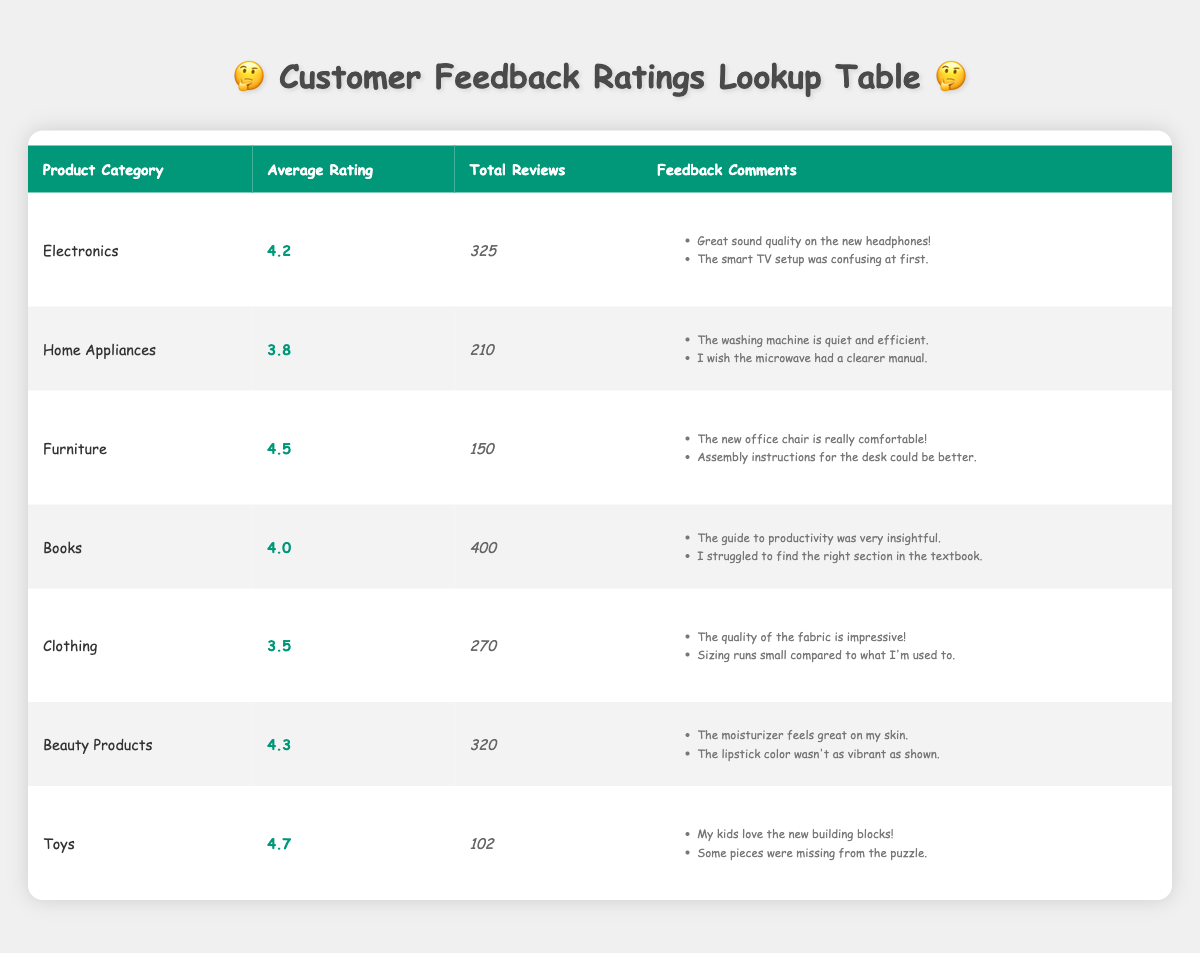What is the average rating for Toys? From the table, we can see that the average rating for the Toys category is listed as 4.7.
Answer: 4.7 How many total reviews were given for Home Appliances? The total reviews for Home Appliances is specified in the table as 210.
Answer: 210 Which product category received the highest average rating? By looking at the average ratings in the table, Toys with an average rating of 4.7 is the highest.
Answer: Toys Is the average rating for Electronics greater than 4.0? The average rating for Electronics is 4.2, which is indeed greater than 4.0.
Answer: Yes What is the total number of reviews for Clothing and Beauty Products combined? The total reviews for Clothing is 270 and for Beauty Products is 320. Adding these gives 270 + 320 = 590.
Answer: 590 Are there any product categories with an average rating of 4.0 or higher? Yes, the categories with an average rating of 4.0 or higher are Electronics, Furniture, Books, Beauty Products, and Toys.
Answer: Yes What is the difference in total reviews between the Books and Toys categories? The total reviews for Books is 400 and for Toys is 102. The difference is calculated as 400 - 102 = 298.
Answer: 298 What feedback comment was common among customers regarding the microwave in Home Appliances? Customers noted that they wished the microwave had a clearer manual, indicating a need for better instructions.
Answer: The microwave had a clearer manual issue Which product category had the least total reviews? The product category with the least total reviews is Toys with only 102 reviews.
Answer: Toys 